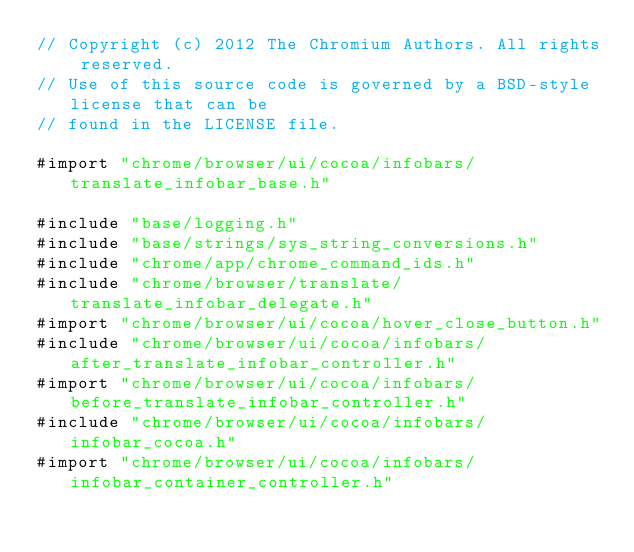<code> <loc_0><loc_0><loc_500><loc_500><_ObjectiveC_>// Copyright (c) 2012 The Chromium Authors. All rights reserved.
// Use of this source code is governed by a BSD-style license that can be
// found in the LICENSE file.

#import "chrome/browser/ui/cocoa/infobars/translate_infobar_base.h"

#include "base/logging.h"
#include "base/strings/sys_string_conversions.h"
#include "chrome/app/chrome_command_ids.h"
#include "chrome/browser/translate/translate_infobar_delegate.h"
#import "chrome/browser/ui/cocoa/hover_close_button.h"
#include "chrome/browser/ui/cocoa/infobars/after_translate_infobar_controller.h"
#import "chrome/browser/ui/cocoa/infobars/before_translate_infobar_controller.h"
#include "chrome/browser/ui/cocoa/infobars/infobar_cocoa.h"
#import "chrome/browser/ui/cocoa/infobars/infobar_container_controller.h"</code> 